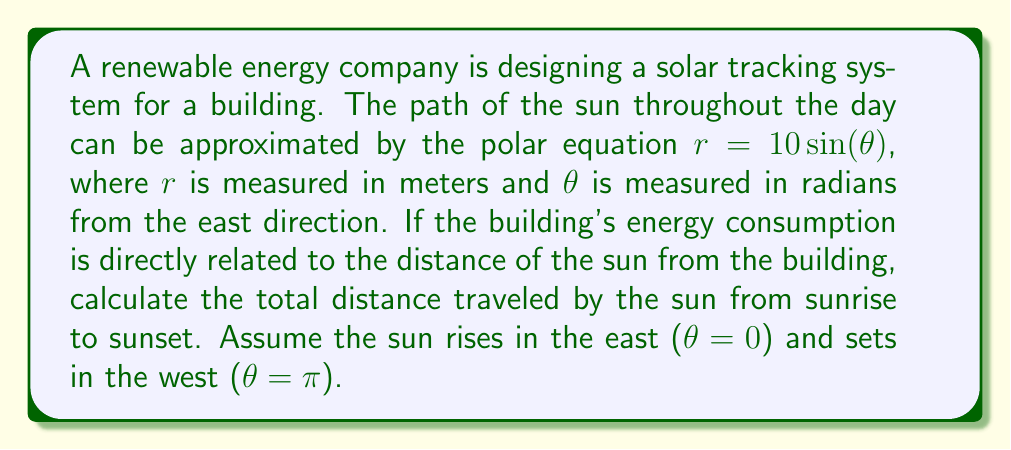Could you help me with this problem? To solve this problem, we need to calculate the arc length of the given polar curve from $\theta = 0$ to $\theta = \pi$. The formula for arc length in polar coordinates is:

$$L = \int_a^b \sqrt{r^2 + \left(\frac{dr}{d\theta}\right)^2} d\theta$$

Given: $r = 10 \sin(\theta)$

Step 1: Calculate $\frac{dr}{d\theta}$
$$\frac{dr}{d\theta} = 10 \cos(\theta)$$

Step 2: Substitute into the arc length formula
$$L = \int_0^\pi \sqrt{(10 \sin(\theta))^2 + (10 \cos(\theta))^2} d\theta$$

Step 3: Simplify the expression under the square root
$$(10 \sin(\theta))^2 + (10 \cos(\theta))^2 = 100 \sin^2(\theta) + 100 \cos^2(\theta) = 100(\sin^2(\theta) + \cos^2(\theta)) = 100$$

Step 4: Simplify the integral
$$L = \int_0^\pi \sqrt{100} d\theta = 10 \int_0^\pi d\theta$$

Step 5: Evaluate the integral
$$L = 10 [\theta]_0^\pi = 10\pi - 0 = 10\pi$$

Therefore, the total distance traveled by the sun from sunrise to sunset is $10\pi$ meters.
Answer: $10\pi$ meters 